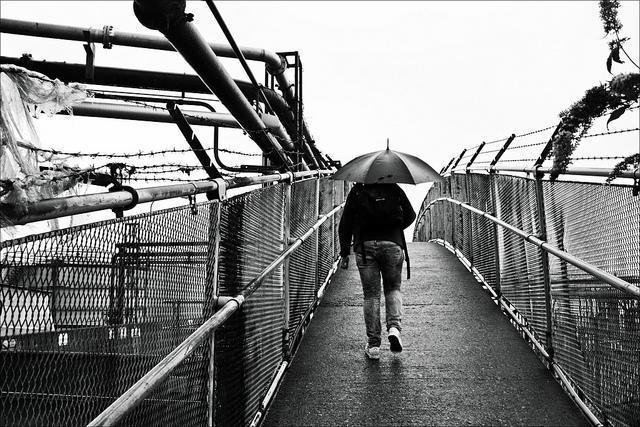How many umbrellas can you see?
Give a very brief answer. 1. 